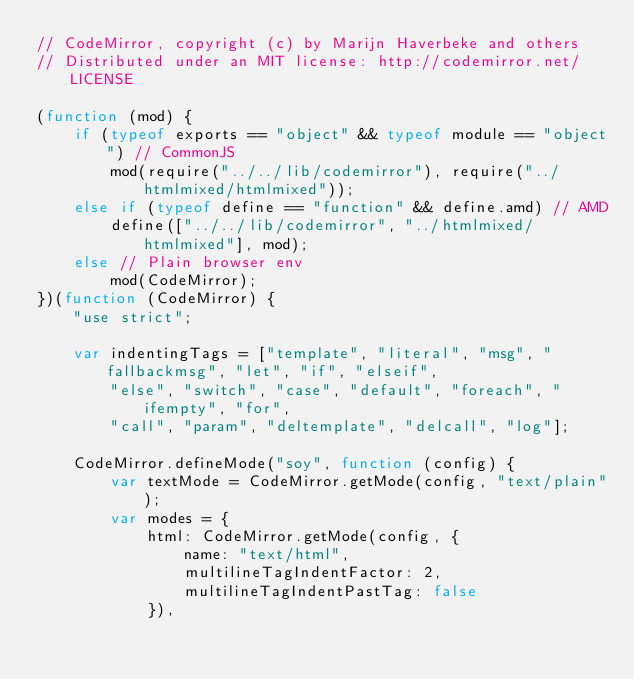<code> <loc_0><loc_0><loc_500><loc_500><_JavaScript_>// CodeMirror, copyright (c) by Marijn Haverbeke and others
// Distributed under an MIT license: http://codemirror.net/LICENSE

(function (mod) {
    if (typeof exports == "object" && typeof module == "object") // CommonJS
        mod(require("../../lib/codemirror"), require("../htmlmixed/htmlmixed"));
    else if (typeof define == "function" && define.amd) // AMD
        define(["../../lib/codemirror", "../htmlmixed/htmlmixed"], mod);
    else // Plain browser env
        mod(CodeMirror);
})(function (CodeMirror) {
    "use strict";

    var indentingTags = ["template", "literal", "msg", "fallbackmsg", "let", "if", "elseif",
        "else", "switch", "case", "default", "foreach", "ifempty", "for",
        "call", "param", "deltemplate", "delcall", "log"];

    CodeMirror.defineMode("soy", function (config) {
        var textMode = CodeMirror.getMode(config, "text/plain");
        var modes = {
            html: CodeMirror.getMode(config, {
                name: "text/html",
                multilineTagIndentFactor: 2,
                multilineTagIndentPastTag: false
            }),</code> 